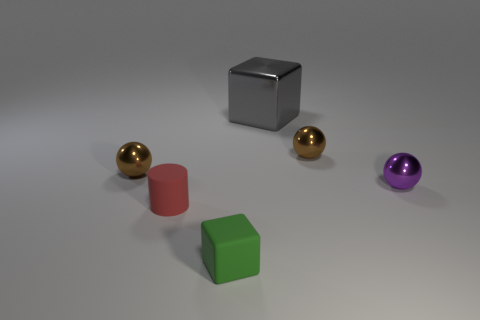The tiny green thing has what shape?
Make the answer very short. Cube. Is the material of the purple ball that is behind the small matte cube the same as the cube in front of the purple metallic sphere?
Your response must be concise. No. The brown object to the left of the tiny green thing has what shape?
Provide a succinct answer. Sphere. There is a gray object that is the same shape as the green object; what size is it?
Make the answer very short. Large. Is there any other thing that is the same shape as the tiny red rubber object?
Your response must be concise. No. Are there any small things on the right side of the tiny metal thing that is on the left side of the red rubber cylinder?
Provide a short and direct response. Yes. The other small object that is the same shape as the gray object is what color?
Offer a very short reply. Green. What number of large metal things have the same color as the rubber cylinder?
Provide a succinct answer. 0. There is a metallic object right of the metal sphere that is behind the tiny object that is to the left of the cylinder; what is its color?
Make the answer very short. Purple. Is the gray object made of the same material as the small purple ball?
Make the answer very short. Yes. 